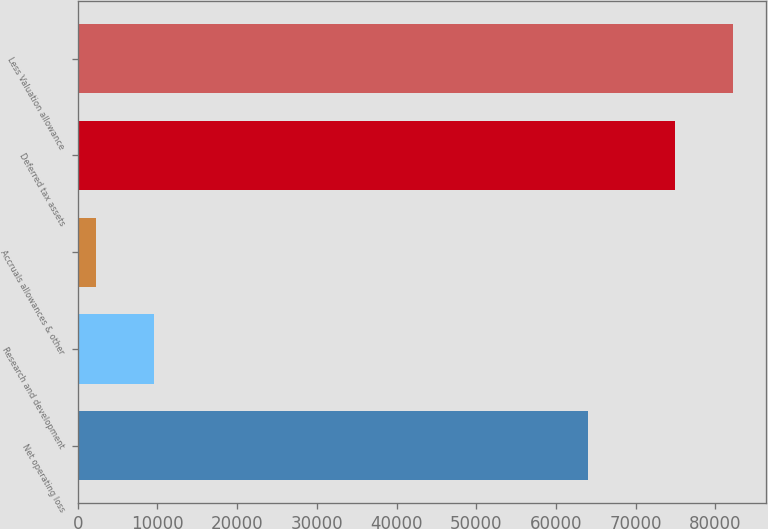<chart> <loc_0><loc_0><loc_500><loc_500><bar_chart><fcel>Net operating loss<fcel>Research and development<fcel>Accruals allowances & other<fcel>Deferred tax assets<fcel>Less Valuation allowance<nl><fcel>63986<fcel>9583.5<fcel>2323<fcel>74928<fcel>82188.5<nl></chart> 